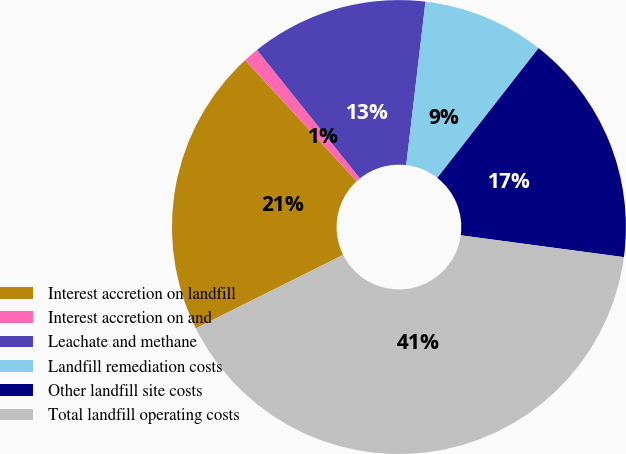Convert chart. <chart><loc_0><loc_0><loc_500><loc_500><pie_chart><fcel>Interest accretion on landfill<fcel>Interest accretion on and<fcel>Leachate and methane<fcel>Landfill remediation costs<fcel>Other landfill site costs<fcel>Total landfill operating costs<nl><fcel>20.51%<fcel>1.1%<fcel>12.62%<fcel>8.68%<fcel>16.57%<fcel>40.52%<nl></chart> 